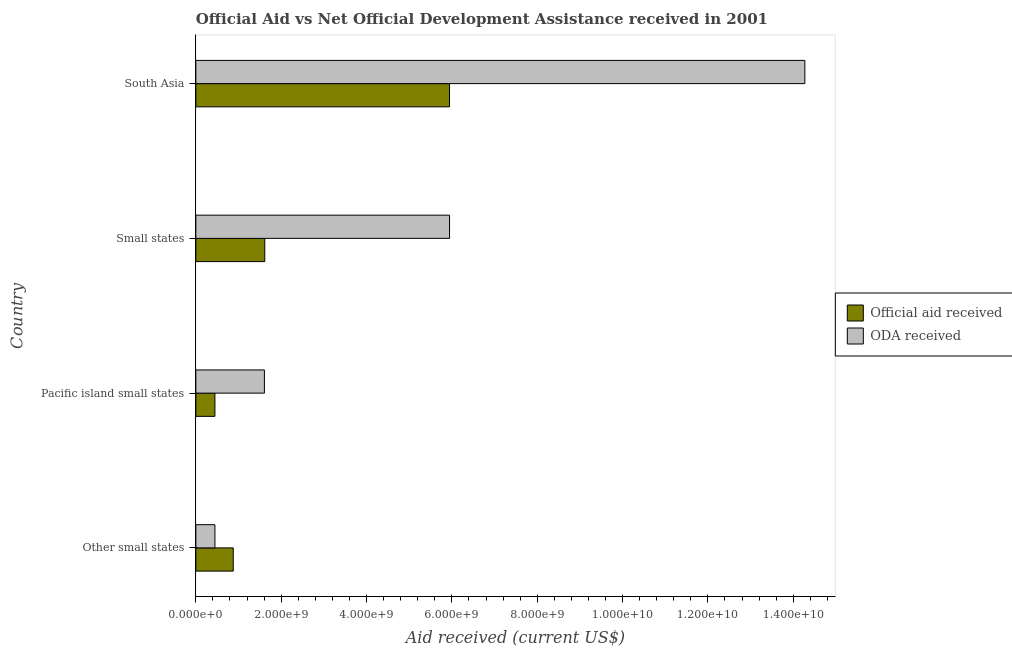How many different coloured bars are there?
Keep it short and to the point. 2. How many groups of bars are there?
Your answer should be compact. 4. Are the number of bars per tick equal to the number of legend labels?
Provide a short and direct response. Yes. What is the label of the 4th group of bars from the top?
Offer a terse response. Other small states. What is the official aid received in Small states?
Ensure brevity in your answer.  1.62e+09. Across all countries, what is the maximum oda received?
Your answer should be very brief. 1.43e+1. Across all countries, what is the minimum official aid received?
Your answer should be compact. 4.48e+08. In which country was the oda received maximum?
Offer a very short reply. South Asia. In which country was the official aid received minimum?
Make the answer very short. Pacific island small states. What is the total official aid received in the graph?
Your answer should be very brief. 8.89e+09. What is the difference between the oda received in Other small states and that in Pacific island small states?
Your response must be concise. -1.16e+09. What is the difference between the oda received in South Asia and the official aid received in Other small states?
Offer a terse response. 1.34e+1. What is the average oda received per country?
Provide a short and direct response. 5.57e+09. What is the difference between the oda received and official aid received in South Asia?
Ensure brevity in your answer.  8.33e+09. What is the ratio of the official aid received in Pacific island small states to that in South Asia?
Keep it short and to the point. 0.07. Is the official aid received in Pacific island small states less than that in South Asia?
Your answer should be compact. Yes. What is the difference between the highest and the second highest oda received?
Make the answer very short. 8.33e+09. What is the difference between the highest and the lowest official aid received?
Keep it short and to the point. 5.50e+09. In how many countries, is the oda received greater than the average oda received taken over all countries?
Give a very brief answer. 2. Is the sum of the official aid received in Small states and South Asia greater than the maximum oda received across all countries?
Your response must be concise. No. What does the 1st bar from the top in Other small states represents?
Keep it short and to the point. ODA received. What does the 1st bar from the bottom in South Asia represents?
Ensure brevity in your answer.  Official aid received. How many countries are there in the graph?
Your response must be concise. 4. Are the values on the major ticks of X-axis written in scientific E-notation?
Provide a succinct answer. Yes. Does the graph contain grids?
Offer a terse response. No. Where does the legend appear in the graph?
Offer a very short reply. Center right. How many legend labels are there?
Offer a very short reply. 2. How are the legend labels stacked?
Keep it short and to the point. Vertical. What is the title of the graph?
Provide a short and direct response. Official Aid vs Net Official Development Assistance received in 2001 . Does "Netherlands" appear as one of the legend labels in the graph?
Keep it short and to the point. No. What is the label or title of the X-axis?
Offer a very short reply. Aid received (current US$). What is the label or title of the Y-axis?
Provide a short and direct response. Country. What is the Aid received (current US$) in Official aid received in Other small states?
Your response must be concise. 8.77e+08. What is the Aid received (current US$) of ODA received in Other small states?
Give a very brief answer. 4.48e+08. What is the Aid received (current US$) in Official aid received in Pacific island small states?
Offer a terse response. 4.48e+08. What is the Aid received (current US$) in ODA received in Pacific island small states?
Provide a succinct answer. 1.61e+09. What is the Aid received (current US$) of Official aid received in Small states?
Make the answer very short. 1.62e+09. What is the Aid received (current US$) of ODA received in Small states?
Your answer should be very brief. 5.95e+09. What is the Aid received (current US$) of Official aid received in South Asia?
Provide a succinct answer. 5.95e+09. What is the Aid received (current US$) in ODA received in South Asia?
Keep it short and to the point. 1.43e+1. Across all countries, what is the maximum Aid received (current US$) of Official aid received?
Your response must be concise. 5.95e+09. Across all countries, what is the maximum Aid received (current US$) in ODA received?
Offer a very short reply. 1.43e+1. Across all countries, what is the minimum Aid received (current US$) in Official aid received?
Offer a terse response. 4.48e+08. Across all countries, what is the minimum Aid received (current US$) of ODA received?
Give a very brief answer. 4.48e+08. What is the total Aid received (current US$) of Official aid received in the graph?
Your answer should be compact. 8.89e+09. What is the total Aid received (current US$) of ODA received in the graph?
Your response must be concise. 2.23e+1. What is the difference between the Aid received (current US$) of Official aid received in Other small states and that in Pacific island small states?
Offer a very short reply. 4.29e+08. What is the difference between the Aid received (current US$) in ODA received in Other small states and that in Pacific island small states?
Provide a succinct answer. -1.16e+09. What is the difference between the Aid received (current US$) in Official aid received in Other small states and that in Small states?
Provide a short and direct response. -7.39e+08. What is the difference between the Aid received (current US$) of ODA received in Other small states and that in Small states?
Give a very brief answer. -5.50e+09. What is the difference between the Aid received (current US$) of Official aid received in Other small states and that in South Asia?
Ensure brevity in your answer.  -5.07e+09. What is the difference between the Aid received (current US$) in ODA received in Other small states and that in South Asia?
Make the answer very short. -1.38e+1. What is the difference between the Aid received (current US$) of Official aid received in Pacific island small states and that in Small states?
Give a very brief answer. -1.17e+09. What is the difference between the Aid received (current US$) of ODA received in Pacific island small states and that in Small states?
Your response must be concise. -4.34e+09. What is the difference between the Aid received (current US$) of Official aid received in Pacific island small states and that in South Asia?
Your answer should be very brief. -5.50e+09. What is the difference between the Aid received (current US$) of ODA received in Pacific island small states and that in South Asia?
Your response must be concise. -1.27e+1. What is the difference between the Aid received (current US$) of Official aid received in Small states and that in South Asia?
Keep it short and to the point. -4.33e+09. What is the difference between the Aid received (current US$) of ODA received in Small states and that in South Asia?
Provide a short and direct response. -8.33e+09. What is the difference between the Aid received (current US$) in Official aid received in Other small states and the Aid received (current US$) in ODA received in Pacific island small states?
Your response must be concise. -7.30e+08. What is the difference between the Aid received (current US$) of Official aid received in Other small states and the Aid received (current US$) of ODA received in Small states?
Provide a short and direct response. -5.07e+09. What is the difference between the Aid received (current US$) of Official aid received in Other small states and the Aid received (current US$) of ODA received in South Asia?
Make the answer very short. -1.34e+1. What is the difference between the Aid received (current US$) of Official aid received in Pacific island small states and the Aid received (current US$) of ODA received in Small states?
Keep it short and to the point. -5.50e+09. What is the difference between the Aid received (current US$) in Official aid received in Pacific island small states and the Aid received (current US$) in ODA received in South Asia?
Ensure brevity in your answer.  -1.38e+1. What is the difference between the Aid received (current US$) in Official aid received in Small states and the Aid received (current US$) in ODA received in South Asia?
Your answer should be compact. -1.27e+1. What is the average Aid received (current US$) of Official aid received per country?
Your answer should be compact. 2.22e+09. What is the average Aid received (current US$) in ODA received per country?
Your answer should be compact. 5.57e+09. What is the difference between the Aid received (current US$) in Official aid received and Aid received (current US$) in ODA received in Other small states?
Offer a terse response. 4.29e+08. What is the difference between the Aid received (current US$) in Official aid received and Aid received (current US$) in ODA received in Pacific island small states?
Ensure brevity in your answer.  -1.16e+09. What is the difference between the Aid received (current US$) in Official aid received and Aid received (current US$) in ODA received in Small states?
Make the answer very short. -4.33e+09. What is the difference between the Aid received (current US$) of Official aid received and Aid received (current US$) of ODA received in South Asia?
Provide a short and direct response. -8.33e+09. What is the ratio of the Aid received (current US$) of Official aid received in Other small states to that in Pacific island small states?
Give a very brief answer. 1.96. What is the ratio of the Aid received (current US$) of ODA received in Other small states to that in Pacific island small states?
Give a very brief answer. 0.28. What is the ratio of the Aid received (current US$) of Official aid received in Other small states to that in Small states?
Your answer should be very brief. 0.54. What is the ratio of the Aid received (current US$) of ODA received in Other small states to that in Small states?
Ensure brevity in your answer.  0.08. What is the ratio of the Aid received (current US$) of Official aid received in Other small states to that in South Asia?
Offer a terse response. 0.15. What is the ratio of the Aid received (current US$) of ODA received in Other small states to that in South Asia?
Your answer should be compact. 0.03. What is the ratio of the Aid received (current US$) of Official aid received in Pacific island small states to that in Small states?
Your answer should be compact. 0.28. What is the ratio of the Aid received (current US$) of ODA received in Pacific island small states to that in Small states?
Your answer should be compact. 0.27. What is the ratio of the Aid received (current US$) in Official aid received in Pacific island small states to that in South Asia?
Give a very brief answer. 0.08. What is the ratio of the Aid received (current US$) in ODA received in Pacific island small states to that in South Asia?
Give a very brief answer. 0.11. What is the ratio of the Aid received (current US$) in Official aid received in Small states to that in South Asia?
Keep it short and to the point. 0.27. What is the ratio of the Aid received (current US$) in ODA received in Small states to that in South Asia?
Provide a succinct answer. 0.42. What is the difference between the highest and the second highest Aid received (current US$) of Official aid received?
Offer a very short reply. 4.33e+09. What is the difference between the highest and the second highest Aid received (current US$) of ODA received?
Keep it short and to the point. 8.33e+09. What is the difference between the highest and the lowest Aid received (current US$) of Official aid received?
Your answer should be compact. 5.50e+09. What is the difference between the highest and the lowest Aid received (current US$) in ODA received?
Give a very brief answer. 1.38e+1. 